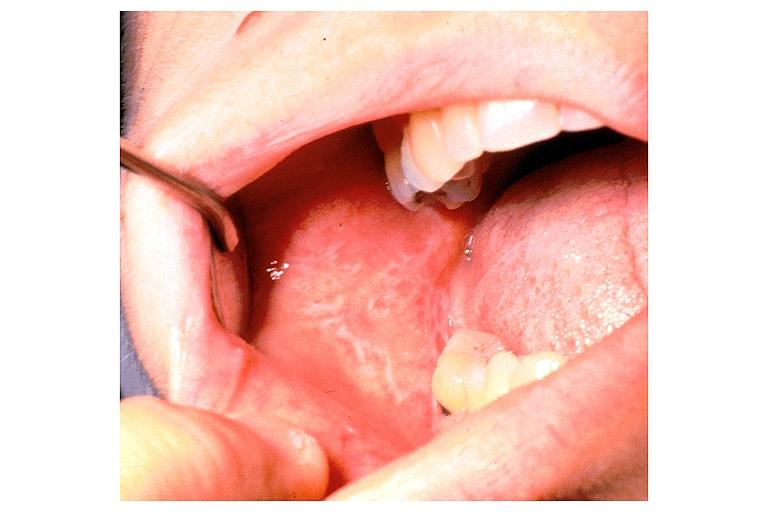s oral present?
Answer the question using a single word or phrase. Yes 